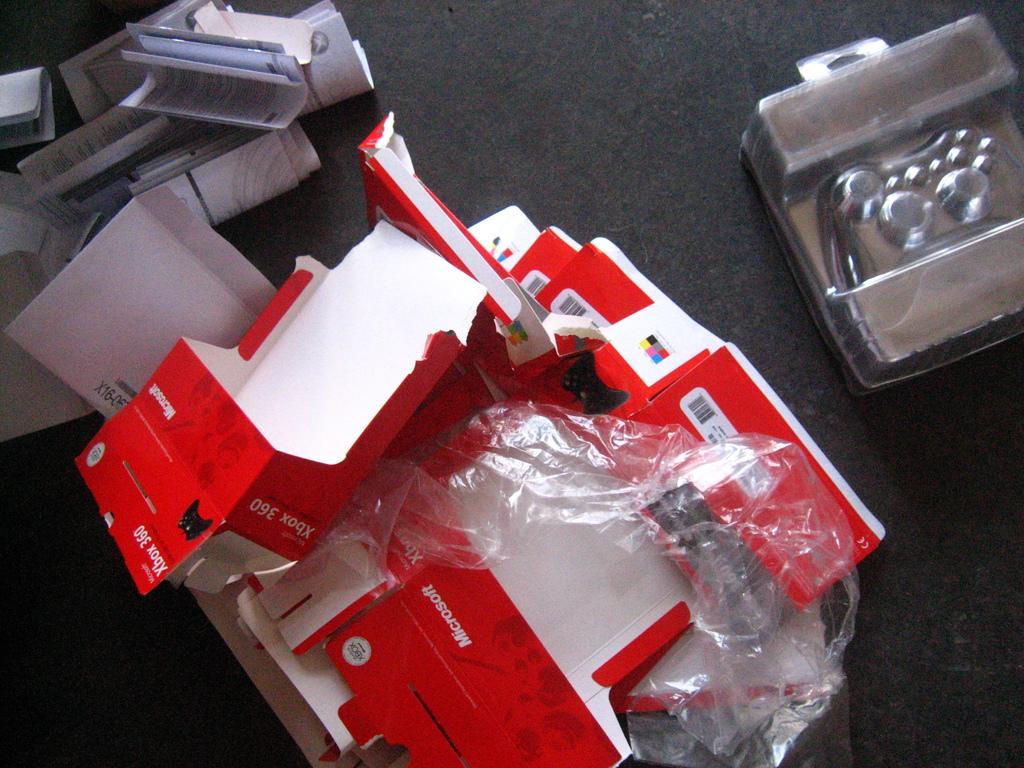Could you give a brief overview of what you see in this image? In this image there are papers and a few other objects on the black color surface. 